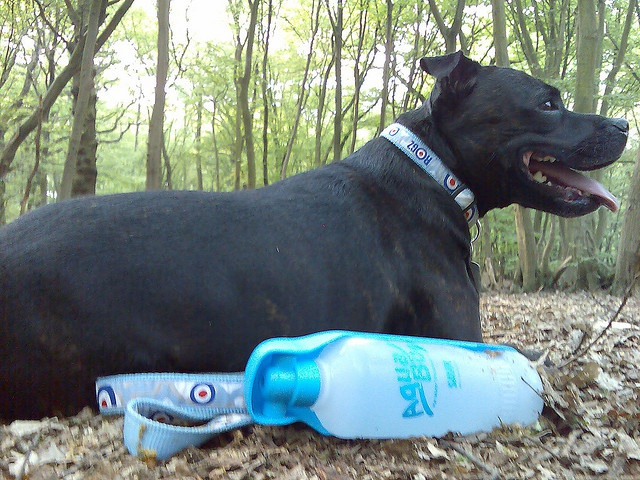Describe the objects in this image and their specific colors. I can see dog in tan, black, gray, and darkblue tones and bottle in tan, lightblue, and cyan tones in this image. 